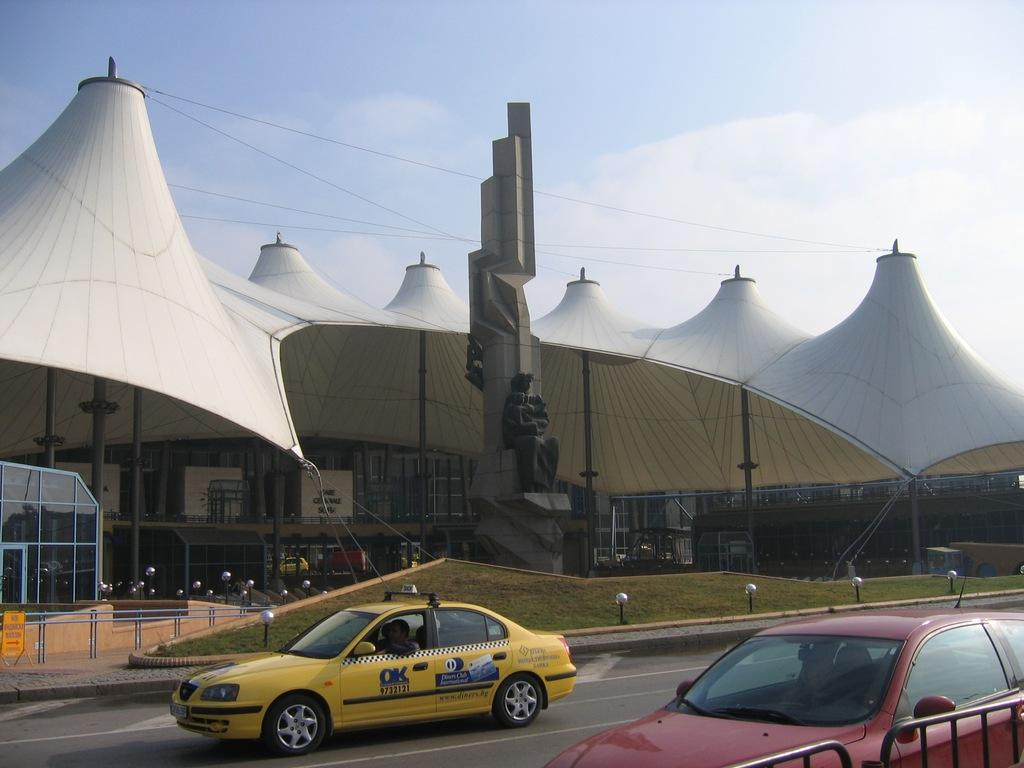<image>
Write a terse but informative summary of the picture. A Diners Club ad is on the side of a taxi. 